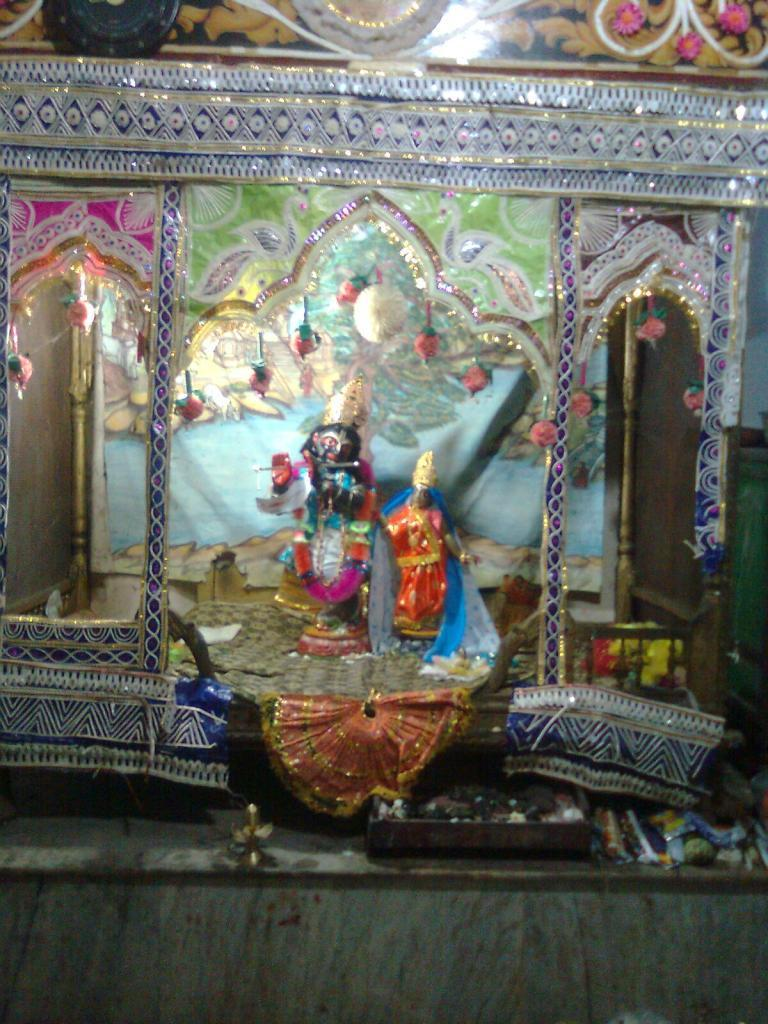What type of statues can be seen in the image? There are two lord statues in the image. What is the surface on which the statues are placed? The image shows a floor. What other objects or decorations are present in the image? There are decorative items in the image. How far away is the truck from the lord statues in the image? There is no truck present in the image, so it is not possible to determine the distance between the statues and a truck. 